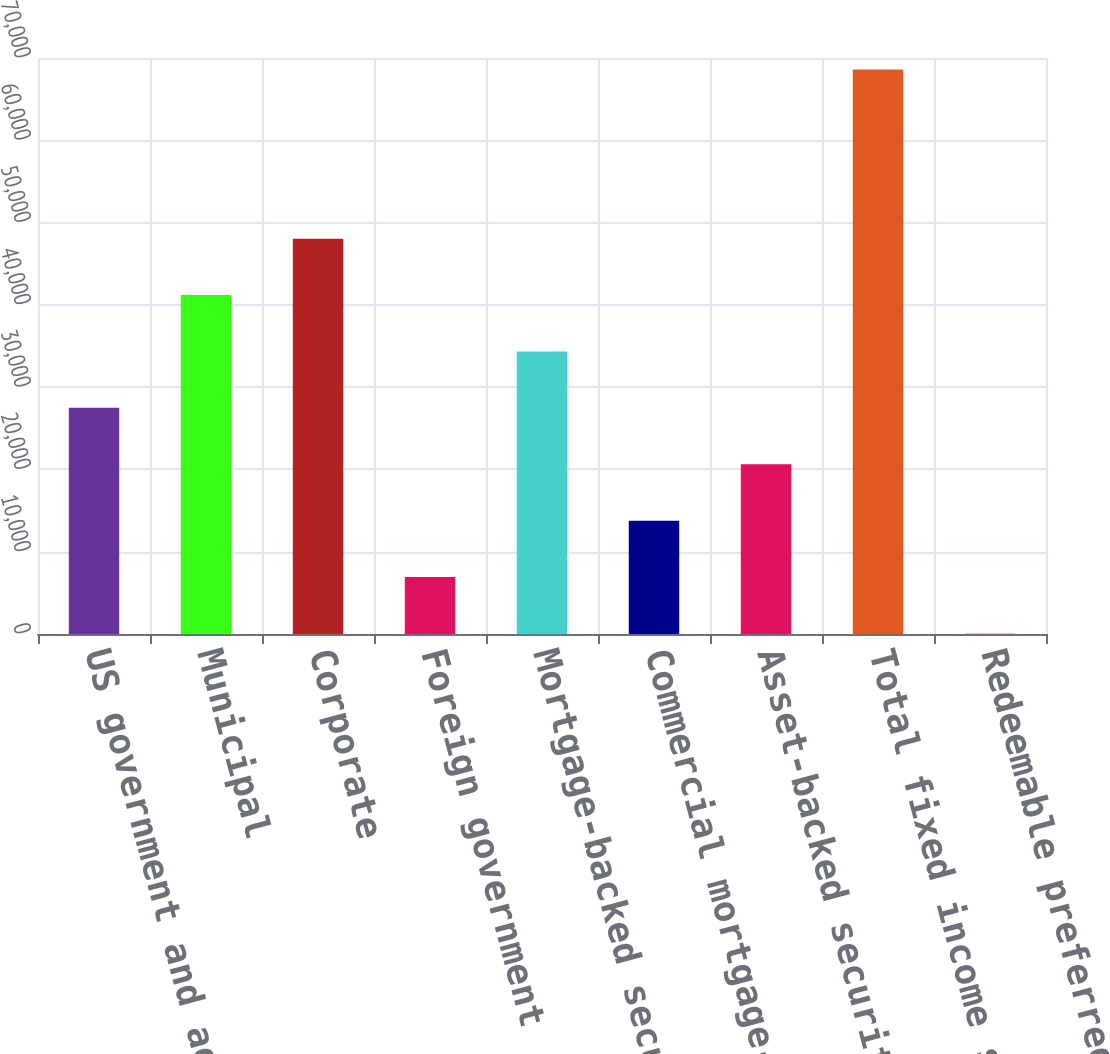<chart> <loc_0><loc_0><loc_500><loc_500><bar_chart><fcel>US government and agencies<fcel>Municipal<fcel>Corporate<fcel>Foreign government<fcel>Mortgage-backed securities<fcel>Commercial mortgage-backed<fcel>Asset-backed securities<fcel>Total fixed income securities<fcel>Redeemable preferred stock<nl><fcel>27482.2<fcel>41190.8<fcel>48045.1<fcel>6919.3<fcel>34336.5<fcel>13773.6<fcel>20627.9<fcel>68608<fcel>65<nl></chart> 